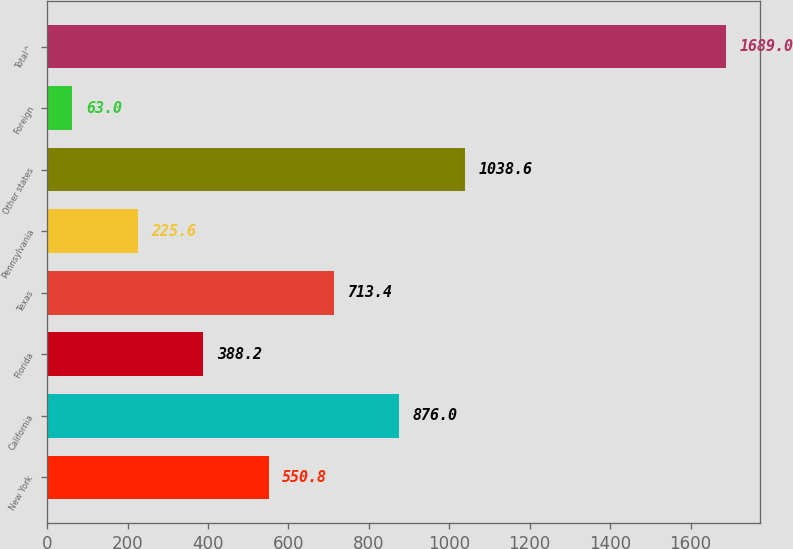Convert chart to OTSL. <chart><loc_0><loc_0><loc_500><loc_500><bar_chart><fcel>New York<fcel>California<fcel>Florida<fcel>Texas<fcel>Pennsylvania<fcel>Other states<fcel>Foreign<fcel>Total^<nl><fcel>550.8<fcel>876<fcel>388.2<fcel>713.4<fcel>225.6<fcel>1038.6<fcel>63<fcel>1689<nl></chart> 